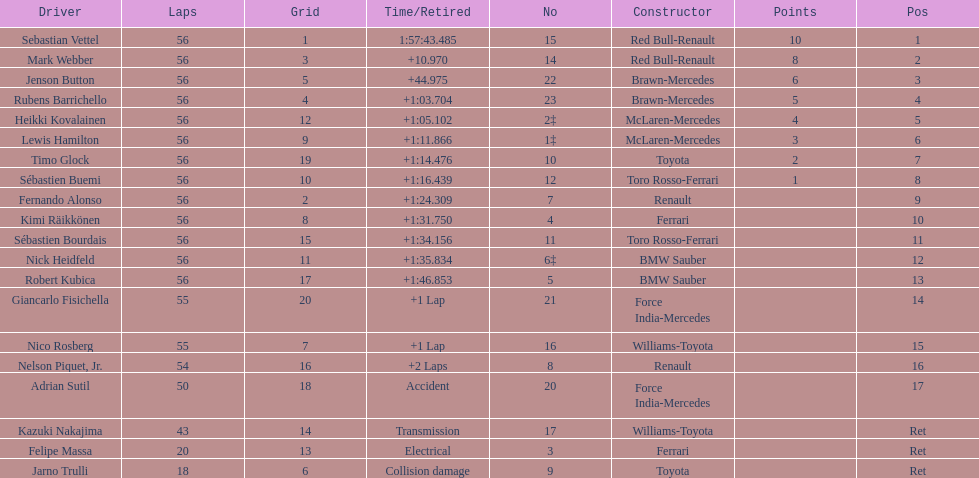Who was the slowest driver to finish the race? Robert Kubica. 